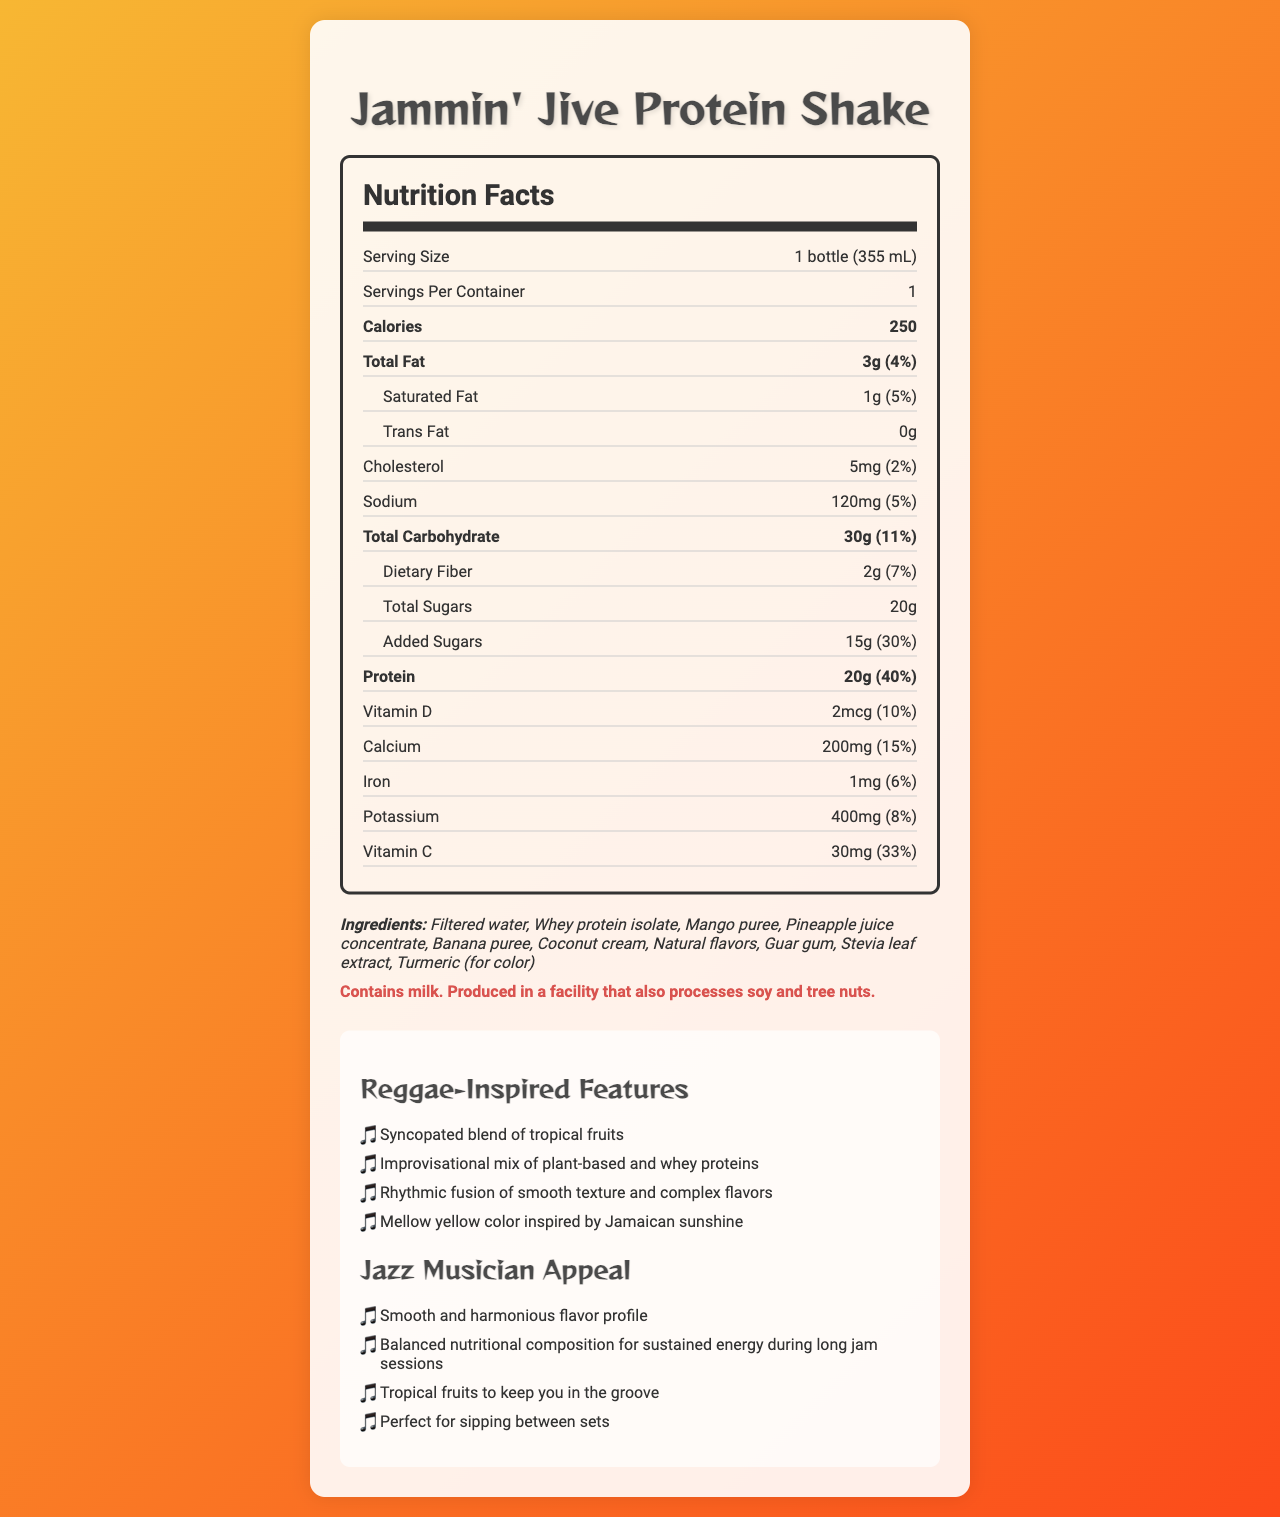what is the serving size of the "Jammin' Jive Protein Shake"? The serving size is listed as "1 bottle (355 mL)" in the nutrition facts section.
Answer: 1 bottle (355 mL) how many calories are there in one serving of the protein shake? The document states that there are 250 calories per serving.
Answer: 250 what is the amount of saturated fat in the shake? The saturated fat is listed as "1g" in the nutrition facts.
Answer: 1g what is the percentage of the daily value of protein provided by one serving? The protein provides 40% of the daily value as indicated in the nutrition section.
Answer: 40% name three tropical fruits included in the ingredients list The ingredients list includes mango puree, pineapple juice concentrate, and banana puree.
Answer: Mango, Pineapple, Banana which nutrient has the highest percentage of daily value in one serving? The protein content in one serving provides 40% of the daily value, which is the highest percentage listed.
Answer: Protein which of the following is NOT an ingredient in the "Jammin' Jive Protein Shake"? A. Coconut cream B. Stevia leaf extract C. Honey The ingredients list includes coconut cream and stevia leaf extract, but not honey.
Answer: C. Honey which vitamin is mentioned with the highest daily value percentage? A. Vitamin D B. Vitamin C C. Calcium D. Iron Vitamin C provides 33% of the daily value, the highest among the vitamins listed.
Answer: B. Vitamin C does the product contain any allergens? The allergen information indicates that the product contains milk and is produced in a facility that also processes soy and tree nuts.
Answer: Yes overall, what is the main idea of the document? This is indicated by the title "Nutrition Facts," the nutrition label, ingredients, allergen information, reggae-inspired features, and jazz musician appeal highlighted throughout the document.
Answer: The document provides detailed nutritional information and features of the "Jammin' Jive Protein Shake," a reggae-themed shake with tropical fruit flavors aimed at those seeking balanced nutrition for sustained energy, particularly appealing to jazz musicians. how much cholesterol is in the shake? The nutrition facts specify that there are 5mg of cholesterol per serving.
Answer: 5mg what are the reggae-inspired features of the protein shake? These features are explicitly listed in the "Reggae-Inspired Features" section of the document.
Answer: Syncopated blend of tropical fruits, Improvisational mix of plant-based and whey proteins, Rhythmic fusion of smooth texture and complex flavors, Mellow yellow color inspired by Jamaican sunshine is the protein shake good for long jam sessions according to the document? One of the jazz musician appeal points states that the shake has a balanced nutritional composition for sustained energy during long jam sessions.
Answer: Yes how much potassium is in one serving? The amount of potassium is listed as 400mg in the nutrition facts section.
Answer: 400mg what is the color of the protein shake inspired by? The document mentions a "Mellow yellow color inspired by Jamaican sunshine" in the reggae-inspired features section.
Answer: Jamaican sunshine can we determine the cost of the "Jammin' Jive Protein Shake" from this document? The document does not provide any details related to the price or cost of the protein shake.
Answer: Not enough information 